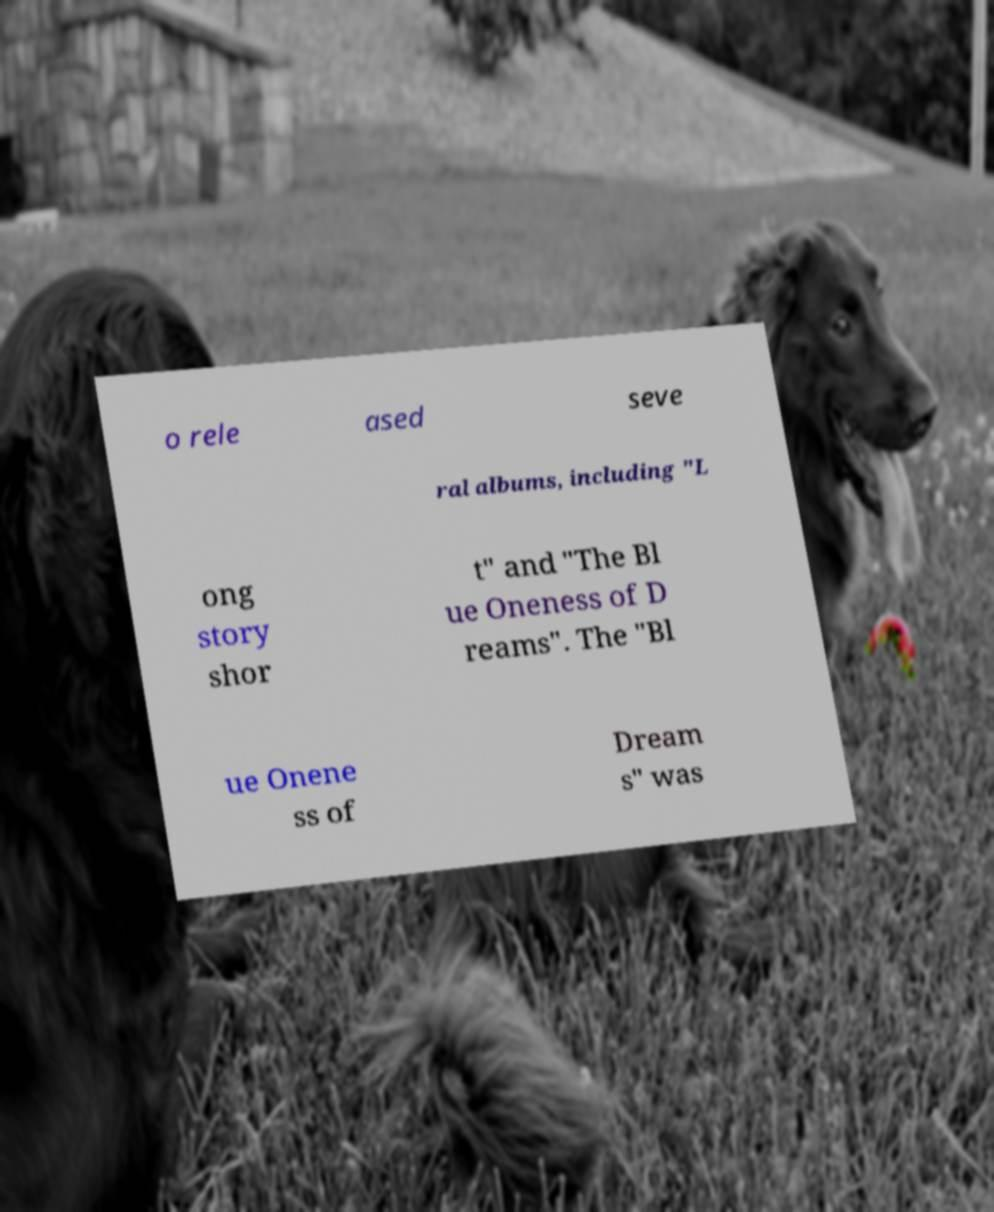Could you assist in decoding the text presented in this image and type it out clearly? o rele ased seve ral albums, including "L ong story shor t" and "The Bl ue Oneness of D reams". The "Bl ue Onene ss of Dream s" was 